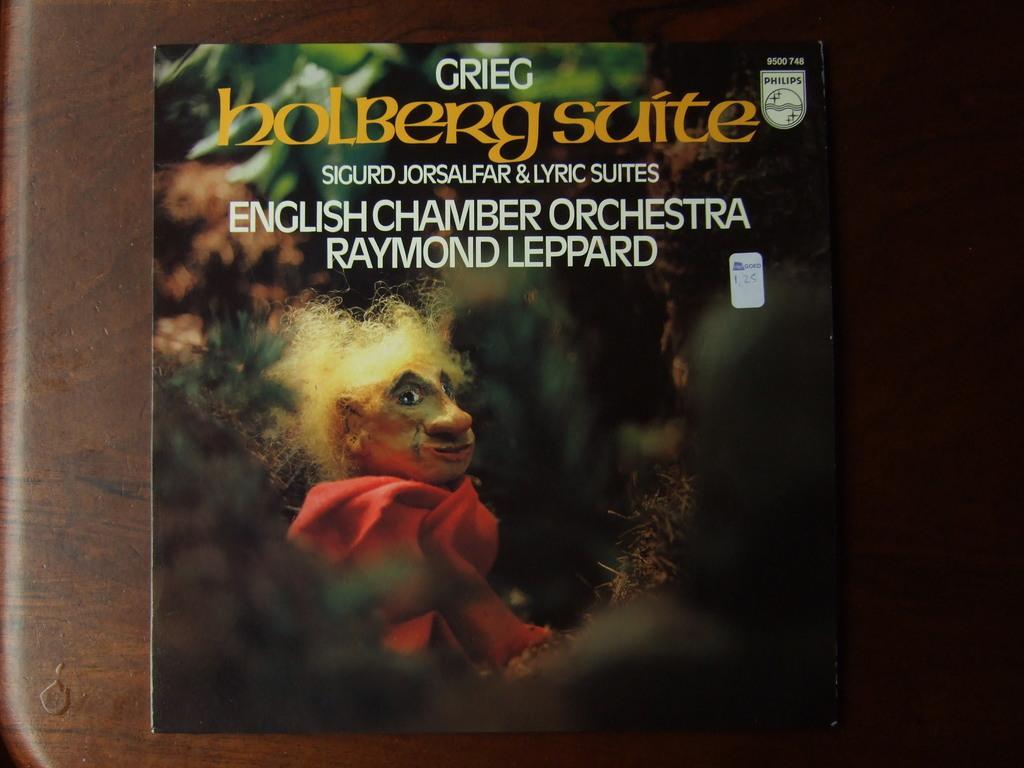Can you describe this image briefly? In this image we can see a poster with text and image on it, it is on the wooden wall. 